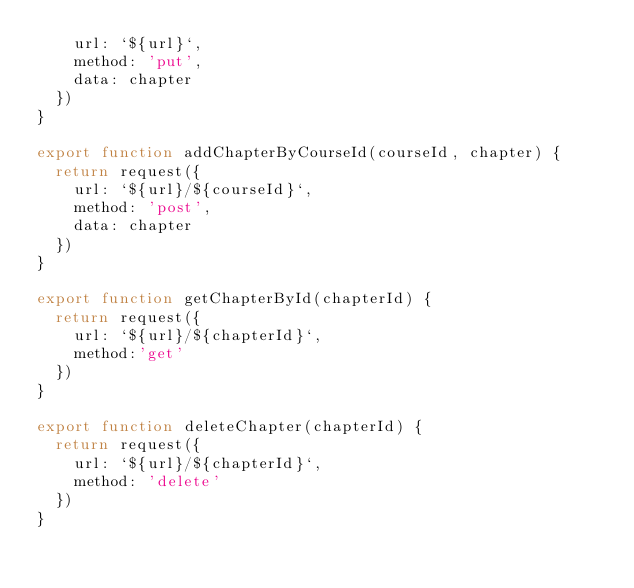Convert code to text. <code><loc_0><loc_0><loc_500><loc_500><_JavaScript_>    url: `${url}`,
    method: 'put',
    data: chapter
  })
}

export function addChapterByCourseId(courseId, chapter) {
  return request({
    url: `${url}/${courseId}`,
    method: 'post',
    data: chapter
  })
}

export function getChapterById(chapterId) {
  return request({
    url: `${url}/${chapterId}`,
    method:'get'
  })
}

export function deleteChapter(chapterId) {
  return request({
    url: `${url}/${chapterId}`,
    method: 'delete'
  })
}
</code> 